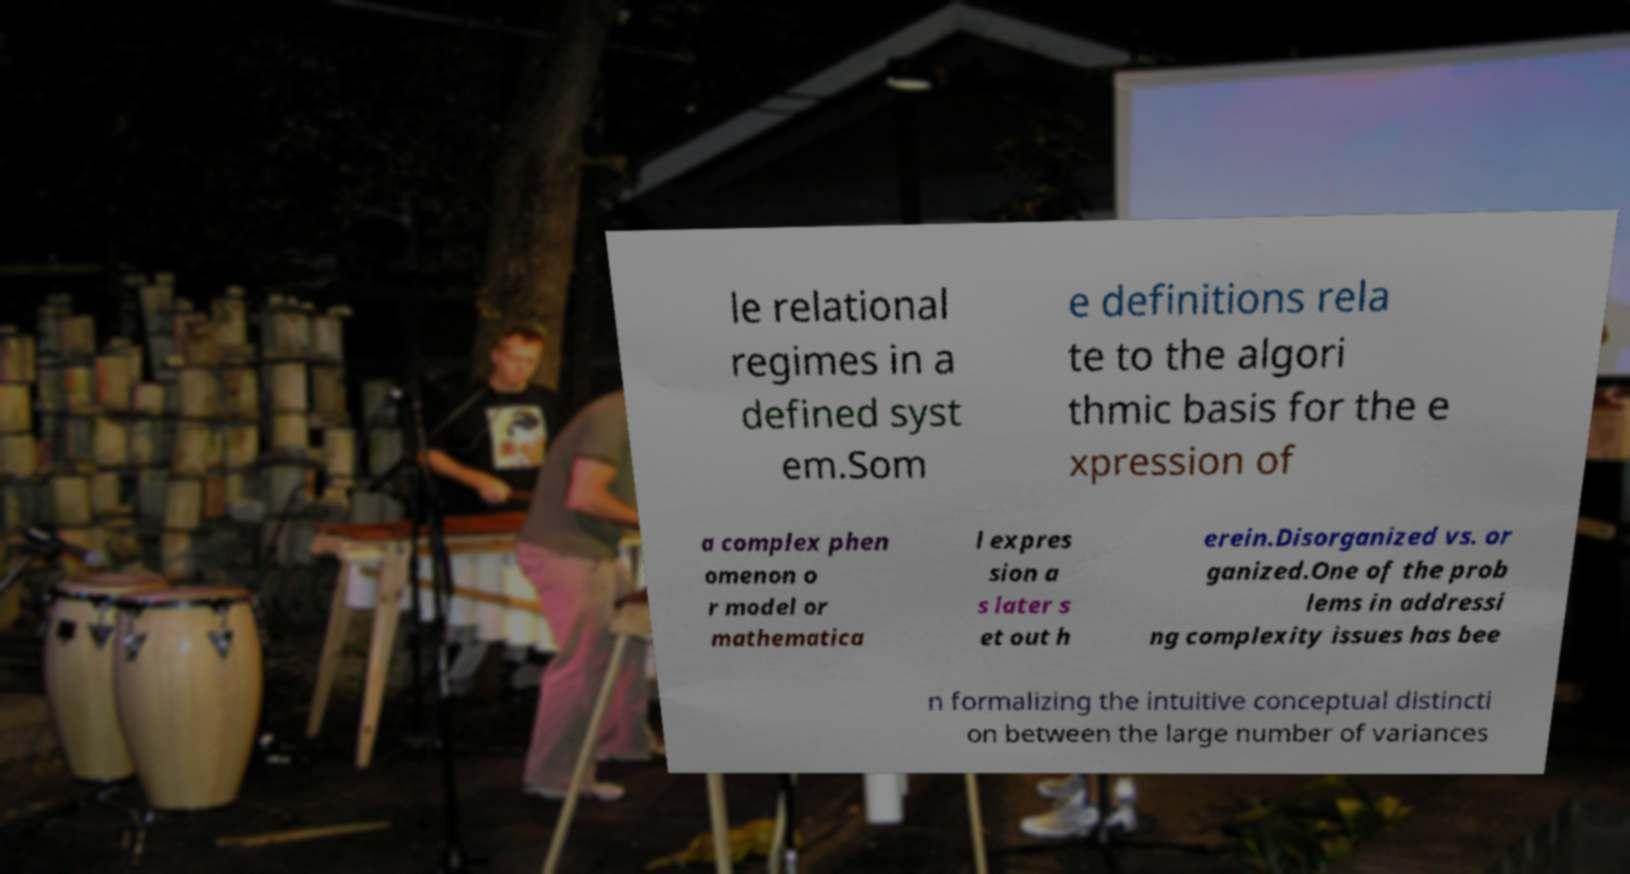Please identify and transcribe the text found in this image. le relational regimes in a defined syst em.Som e definitions rela te to the algori thmic basis for the e xpression of a complex phen omenon o r model or mathematica l expres sion a s later s et out h erein.Disorganized vs. or ganized.One of the prob lems in addressi ng complexity issues has bee n formalizing the intuitive conceptual distincti on between the large number of variances 